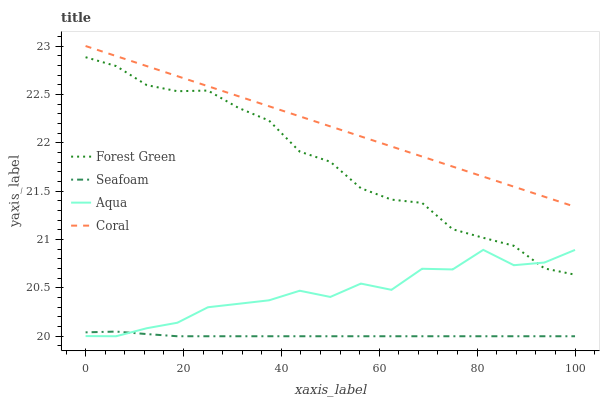Does Seafoam have the minimum area under the curve?
Answer yes or no. Yes. Does Coral have the maximum area under the curve?
Answer yes or no. Yes. Does Forest Green have the minimum area under the curve?
Answer yes or no. No. Does Forest Green have the maximum area under the curve?
Answer yes or no. No. Is Coral the smoothest?
Answer yes or no. Yes. Is Aqua the roughest?
Answer yes or no. Yes. Is Forest Green the smoothest?
Answer yes or no. No. Is Forest Green the roughest?
Answer yes or no. No. Does Forest Green have the lowest value?
Answer yes or no. No. Does Coral have the highest value?
Answer yes or no. Yes. Does Forest Green have the highest value?
Answer yes or no. No. Is Aqua less than Coral?
Answer yes or no. Yes. Is Forest Green greater than Seafoam?
Answer yes or no. Yes. Does Aqua intersect Forest Green?
Answer yes or no. Yes. Is Aqua less than Forest Green?
Answer yes or no. No. Is Aqua greater than Forest Green?
Answer yes or no. No. Does Aqua intersect Coral?
Answer yes or no. No. 